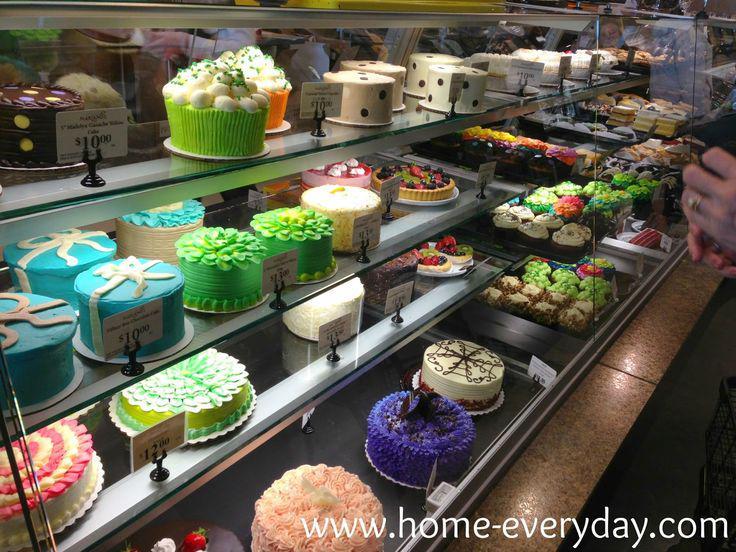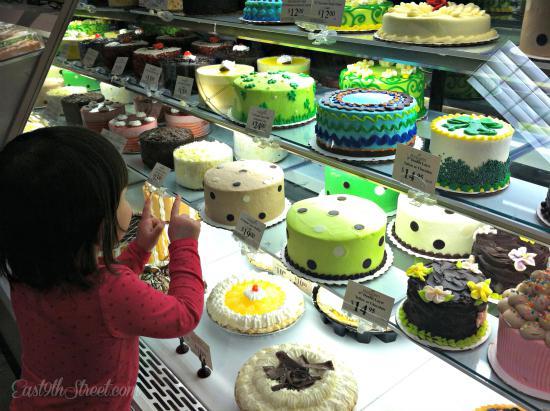The first image is the image on the left, the second image is the image on the right. Analyze the images presented: Is the assertion "The display case on the right contains mostly round cake-like desserts that aren't covered in sliced fruits." valid? Answer yes or no. Yes. 